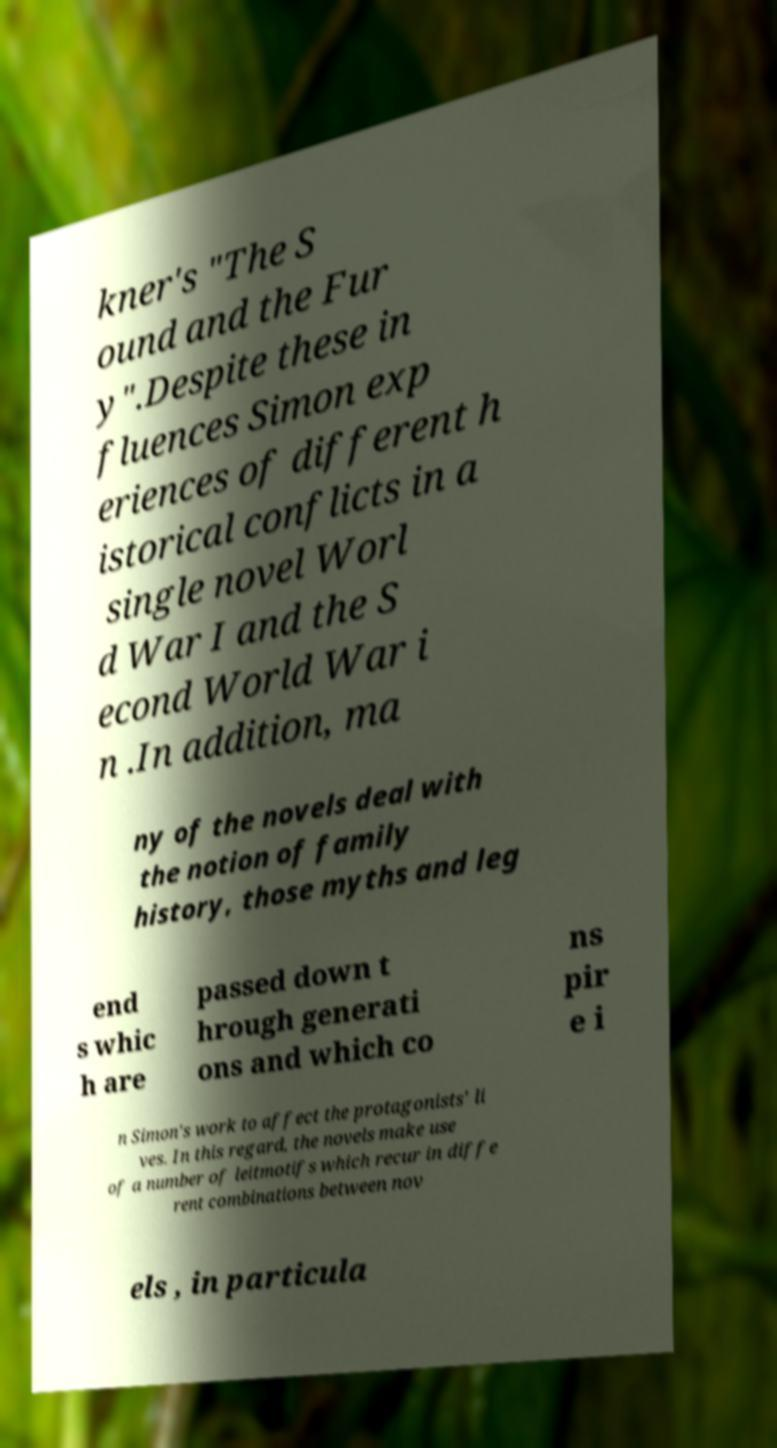Can you accurately transcribe the text from the provided image for me? kner's "The S ound and the Fur y".Despite these in fluences Simon exp eriences of different h istorical conflicts in a single novel Worl d War I and the S econd World War i n .In addition, ma ny of the novels deal with the notion of family history, those myths and leg end s whic h are passed down t hrough generati ons and which co ns pir e i n Simon's work to affect the protagonists' li ves. In this regard, the novels make use of a number of leitmotifs which recur in diffe rent combinations between nov els , in particula 